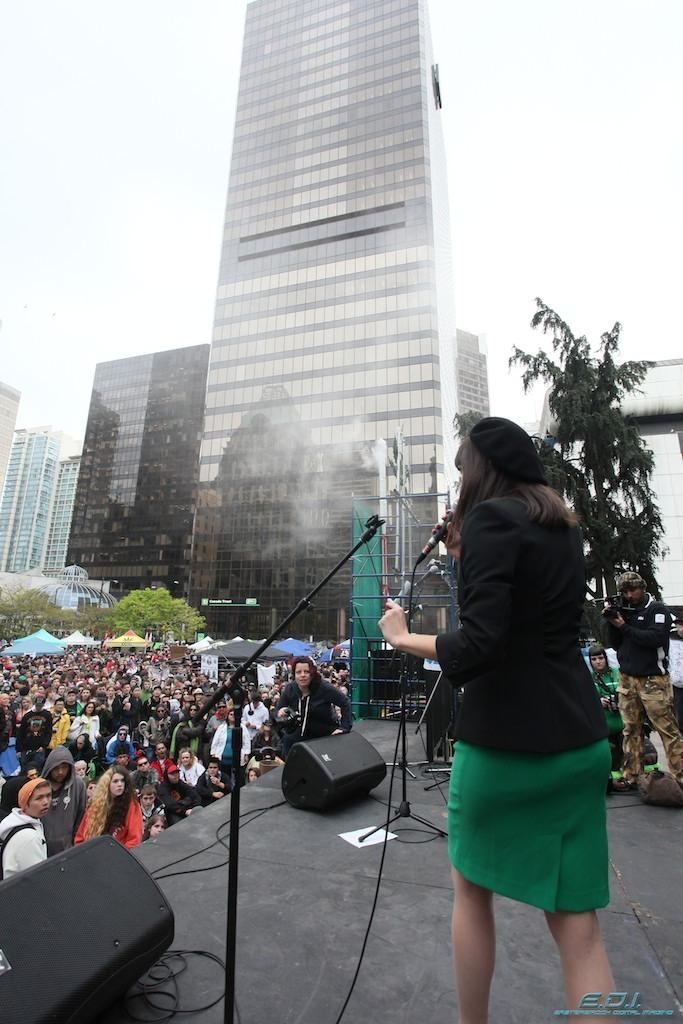What is the woman doing in the image? The woman is standing on the stage. Where are the people located in the image? The people are on the left side of the image. What can be seen in the background of the image? There is a building in the background of the image. What type of steam is coming from the woman's mouth in the image? There is no steam coming from the woman's mouth in the image. 